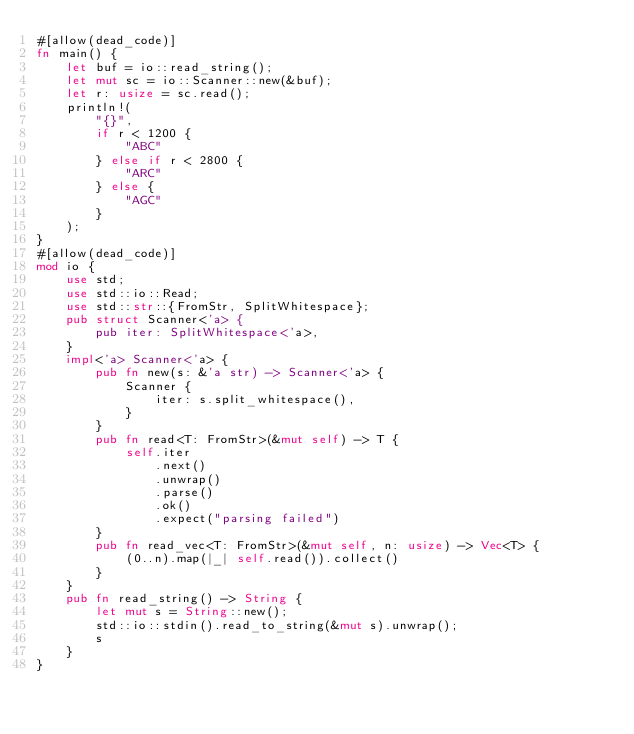Convert code to text. <code><loc_0><loc_0><loc_500><loc_500><_Rust_>#[allow(dead_code)]
fn main() {
    let buf = io::read_string();
    let mut sc = io::Scanner::new(&buf);
    let r: usize = sc.read();
    println!(
        "{}",
        if r < 1200 {
            "ABC"
        } else if r < 2800 {
            "ARC"
        } else {
            "AGC"
        }
    );
}
#[allow(dead_code)]
mod io {
    use std;
    use std::io::Read;
    use std::str::{FromStr, SplitWhitespace};
    pub struct Scanner<'a> {
        pub iter: SplitWhitespace<'a>,
    }
    impl<'a> Scanner<'a> {
        pub fn new(s: &'a str) -> Scanner<'a> {
            Scanner {
                iter: s.split_whitespace(),
            }
        }
        pub fn read<T: FromStr>(&mut self) -> T {
            self.iter
                .next()
                .unwrap()
                .parse()
                .ok()
                .expect("parsing failed")
        }
        pub fn read_vec<T: FromStr>(&mut self, n: usize) -> Vec<T> {
            (0..n).map(|_| self.read()).collect()
        }
    }
    pub fn read_string() -> String {
        let mut s = String::new();
        std::io::stdin().read_to_string(&mut s).unwrap();
        s
    }
}
</code> 